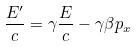Convert formula to latex. <formula><loc_0><loc_0><loc_500><loc_500>\frac { E ^ { \prime } } { c } = \gamma \frac { E } { c } - \gamma \beta p _ { x }</formula> 